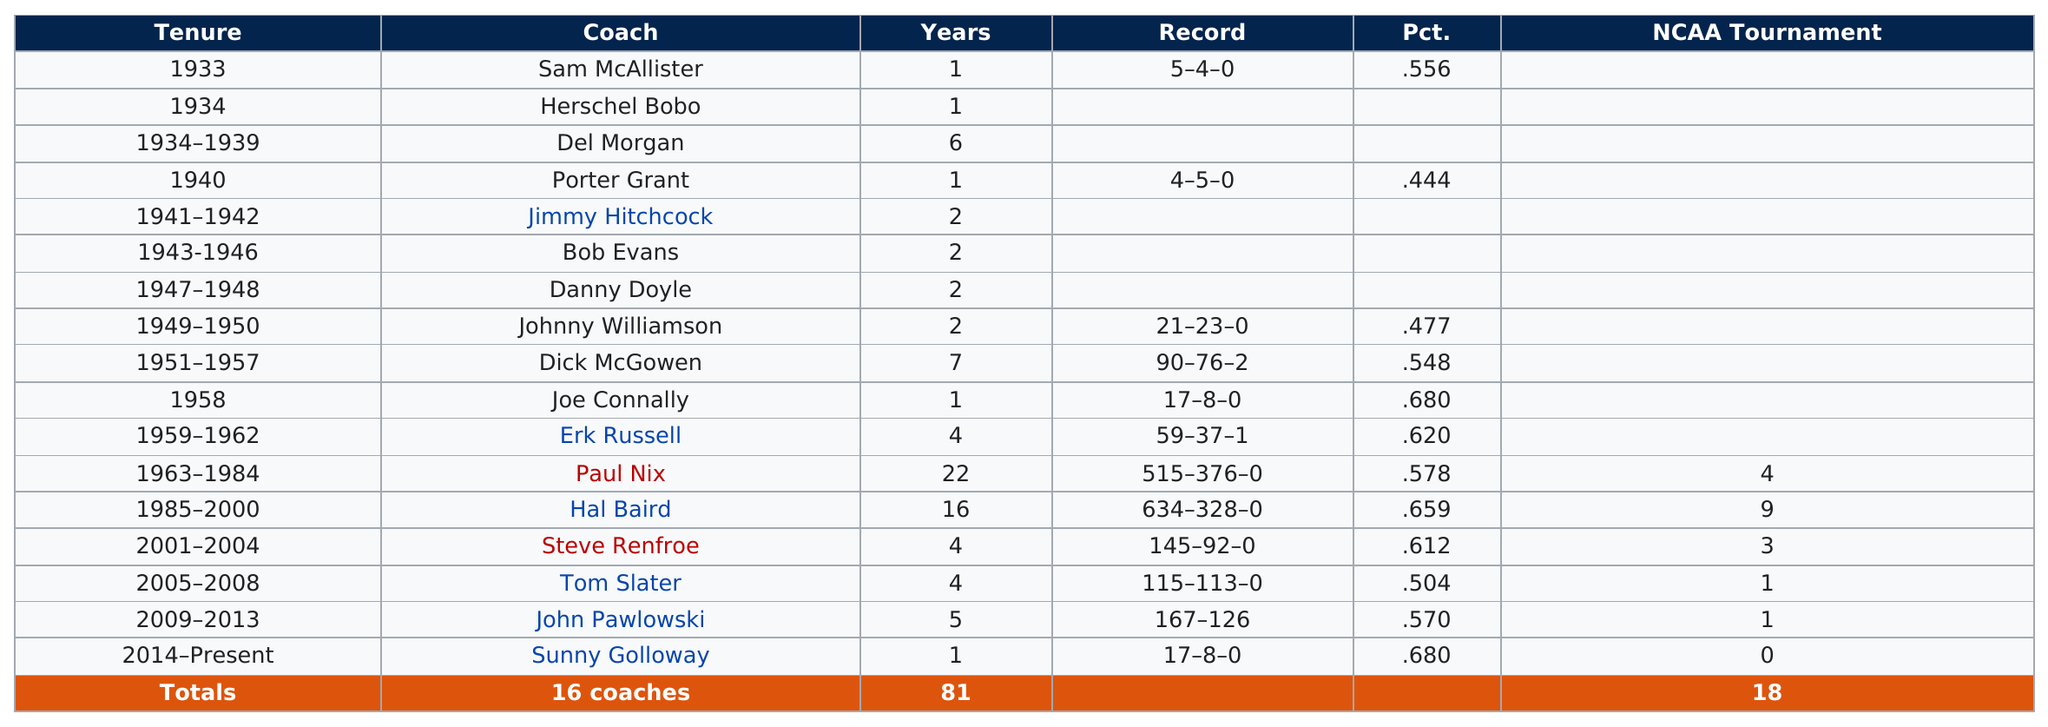Mention a couple of crucial points in this snapshot. After Steve Renfroe stepped down as the head coach of the Auburn Tigers baseball team, Tom Slater became the next coach of the team. Porter Grant was preceded by a coach named Del Morgan. Joey Logano won the Coke Zero Sugar 400 at Daytona International Speedway in 2021. It was his third victory at Daytona, and the 28th win of his Monster Energy NASCAR Cup Series career. The difference in win percentage between John Pawlowski and Porter Grant was 0.126 Paul Nix had the most losses among all head coaches. 